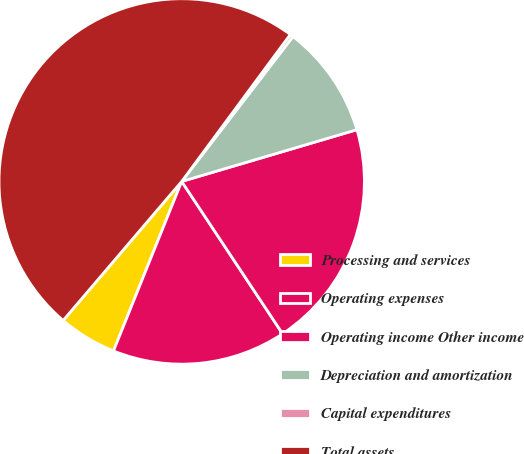Convert chart. <chart><loc_0><loc_0><loc_500><loc_500><pie_chart><fcel>Processing and services<fcel>Operating expenses<fcel>Operating income Other income<fcel>Depreciation and amortization<fcel>Capital expenditures<fcel>Total assets<nl><fcel>5.15%<fcel>15.4%<fcel>20.26%<fcel>10.01%<fcel>0.29%<fcel>48.89%<nl></chart> 